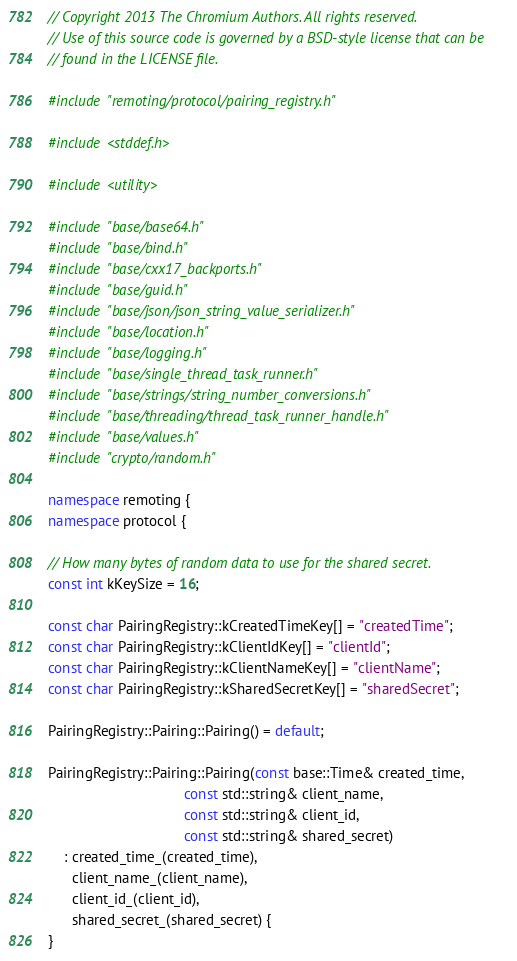Convert code to text. <code><loc_0><loc_0><loc_500><loc_500><_C++_>// Copyright 2013 The Chromium Authors. All rights reserved.
// Use of this source code is governed by a BSD-style license that can be
// found in the LICENSE file.

#include "remoting/protocol/pairing_registry.h"

#include <stddef.h>

#include <utility>

#include "base/base64.h"
#include "base/bind.h"
#include "base/cxx17_backports.h"
#include "base/guid.h"
#include "base/json/json_string_value_serializer.h"
#include "base/location.h"
#include "base/logging.h"
#include "base/single_thread_task_runner.h"
#include "base/strings/string_number_conversions.h"
#include "base/threading/thread_task_runner_handle.h"
#include "base/values.h"
#include "crypto/random.h"

namespace remoting {
namespace protocol {

// How many bytes of random data to use for the shared secret.
const int kKeySize = 16;

const char PairingRegistry::kCreatedTimeKey[] = "createdTime";
const char PairingRegistry::kClientIdKey[] = "clientId";
const char PairingRegistry::kClientNameKey[] = "clientName";
const char PairingRegistry::kSharedSecretKey[] = "sharedSecret";

PairingRegistry::Pairing::Pairing() = default;

PairingRegistry::Pairing::Pairing(const base::Time& created_time,
                                  const std::string& client_name,
                                  const std::string& client_id,
                                  const std::string& shared_secret)
    : created_time_(created_time),
      client_name_(client_name),
      client_id_(client_id),
      shared_secret_(shared_secret) {
}
</code> 